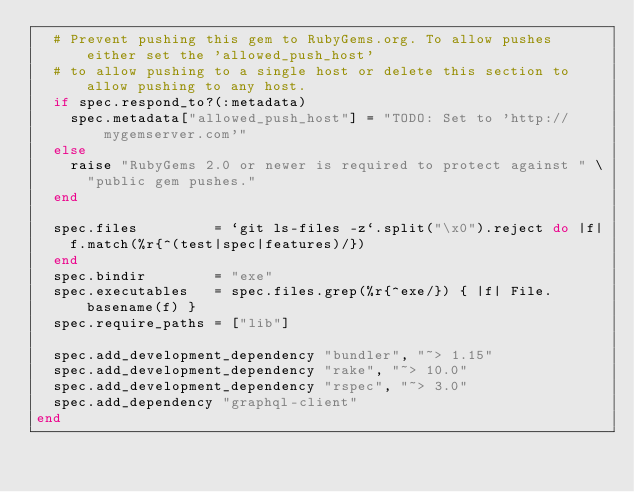<code> <loc_0><loc_0><loc_500><loc_500><_Ruby_>  # Prevent pushing this gem to RubyGems.org. To allow pushes either set the 'allowed_push_host'
  # to allow pushing to a single host or delete this section to allow pushing to any host.
  if spec.respond_to?(:metadata)
    spec.metadata["allowed_push_host"] = "TODO: Set to 'http://mygemserver.com'"
  else
    raise "RubyGems 2.0 or newer is required to protect against " \
      "public gem pushes."
  end

  spec.files         = `git ls-files -z`.split("\x0").reject do |f|
    f.match(%r{^(test|spec|features)/})
  end
  spec.bindir        = "exe"
  spec.executables   = spec.files.grep(%r{^exe/}) { |f| File.basename(f) }
  spec.require_paths = ["lib"]

  spec.add_development_dependency "bundler", "~> 1.15"
  spec.add_development_dependency "rake", "~> 10.0"
  spec.add_development_dependency "rspec", "~> 3.0"
  spec.add_dependency "graphql-client"
end
</code> 